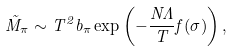<formula> <loc_0><loc_0><loc_500><loc_500>\tilde { M } _ { \pi } \sim T ^ { 2 } b _ { \pi } \exp \left ( - \frac { N \Lambda } { T } f ( \sigma ) \right ) ,</formula> 